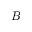Convert formula to latex. <formula><loc_0><loc_0><loc_500><loc_500>B</formula> 